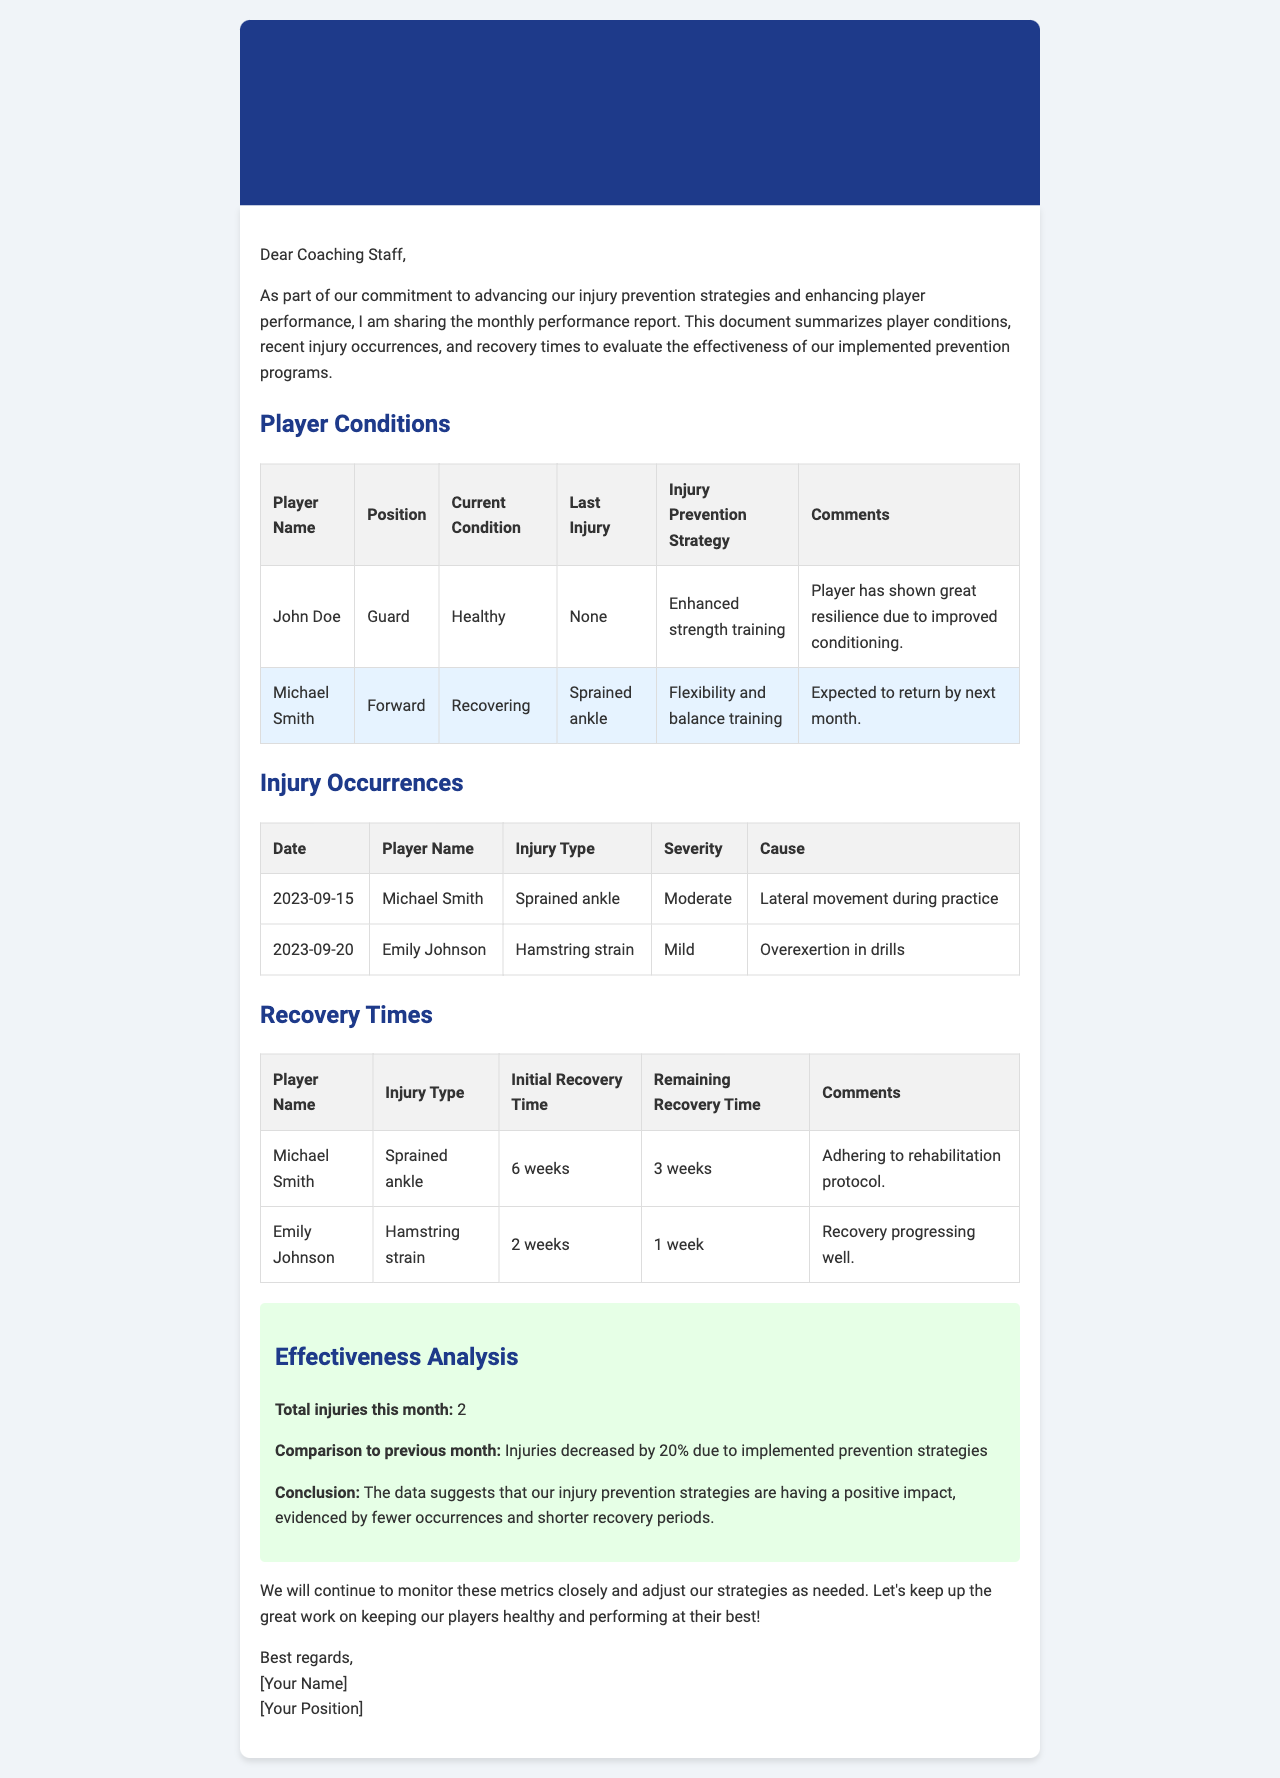What is the title of the report? The title of the report is stated in the header section of the document.
Answer: Monthly Performance Report on Player Condition and Injury Prevention Who is the first player listed as recovering? The player listed in the table under the "Recovering" condition is specified in the "Player Conditions" section.
Answer: Michael Smith What is the injury type for Emily Johnson? The injury type for Emily Johnson is mentioned in the "Injury Occurrences" table.
Answer: Hamstring strain How many total injuries occurred this month? The total number of injuries is stated in the effectiveness analysis section of the document.
Answer: 2 What was the decrease in injuries compared to the previous month? The percentage change in injuries is also found in the effectiveness analysis section.
Answer: 20% What is the expected return timeframe for Michael Smith? The expected return timeframe for Michael Smith is provided in the "Player Conditions" table.
Answer: By next month Who provided the report? The sender's name is located at the end of the document.
Answer: [Your Name] 